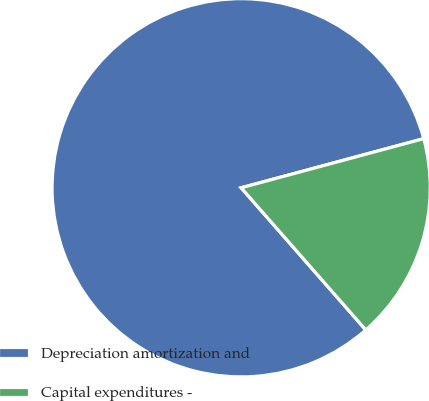Convert chart to OTSL. <chart><loc_0><loc_0><loc_500><loc_500><pie_chart><fcel>Depreciation amortization and<fcel>Capital expenditures -<nl><fcel>82.27%<fcel>17.73%<nl></chart> 